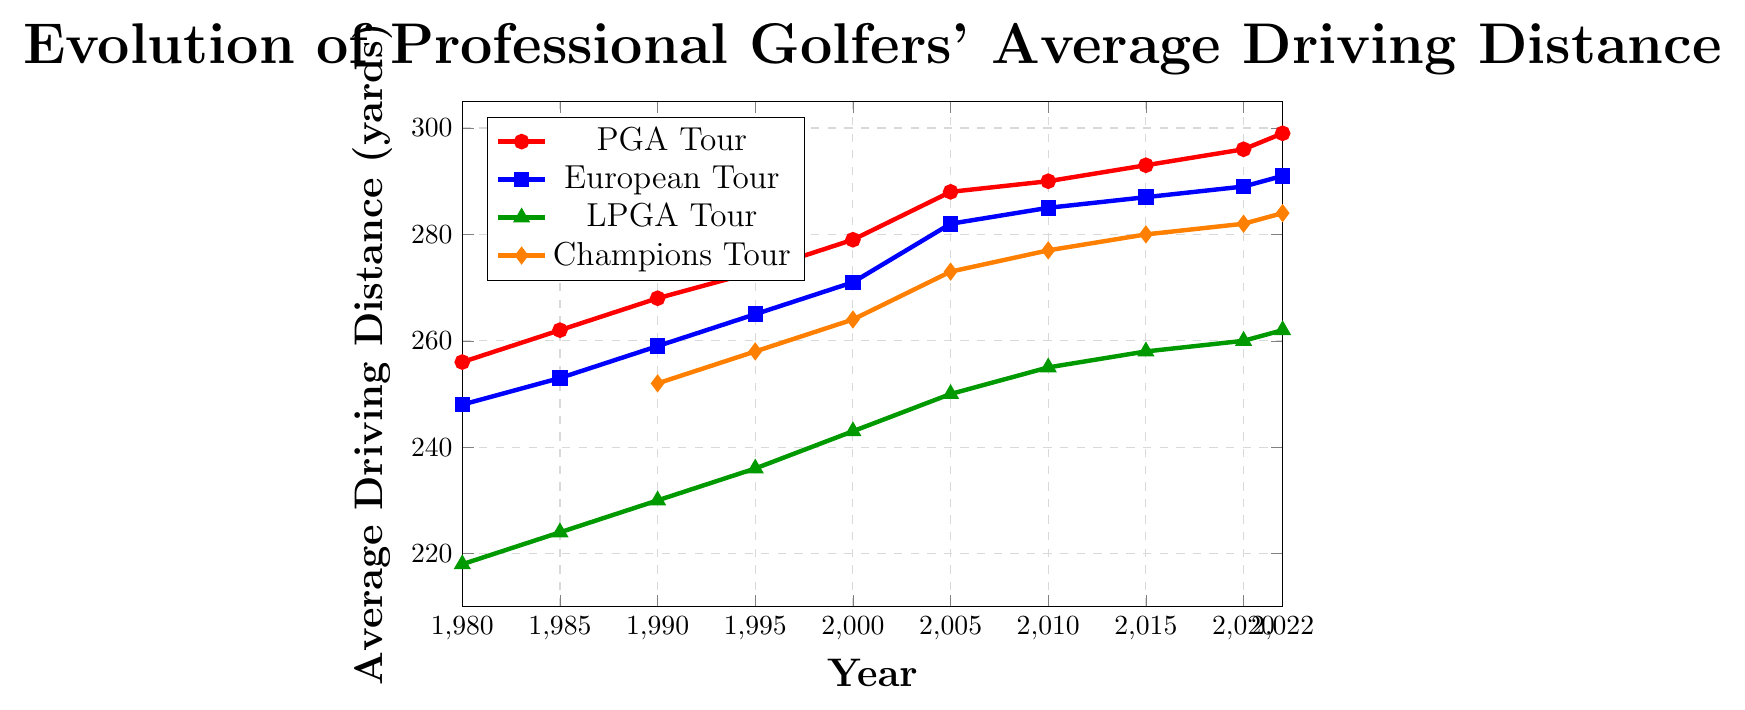What's the average driving distance for the PGA Tour in 2000 and 2020? The average driving distance for the PGA Tour can be found by adding the values for 2000 and 2020 and then dividing by 2. The values are 279 yards in 2000 and 296 yards in 2020. So, \( (279 + 296)/2 = 575/2 = 287.5 \) yards.
Answer: 287.5 What is the difference in average driving distance between the LPGA Tour and the European Tour in 2022? The value for the LPGA Tour in 2022 is 262 yards, and the European Tour value in 2022 is 291 yards. The difference is \( 291 - 262 = 29 \) yards.
Answer: 29 